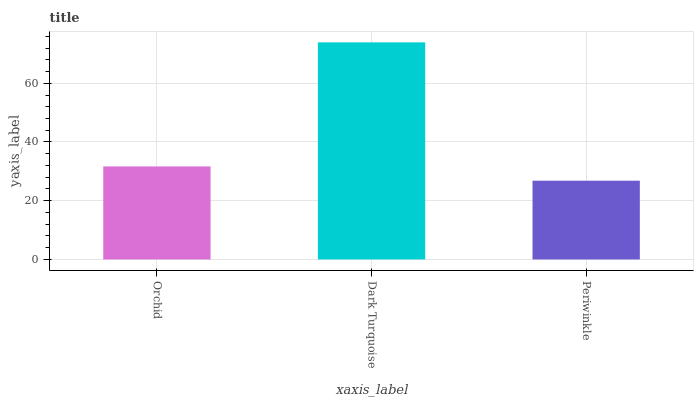Is Periwinkle the minimum?
Answer yes or no. Yes. Is Dark Turquoise the maximum?
Answer yes or no. Yes. Is Dark Turquoise the minimum?
Answer yes or no. No. Is Periwinkle the maximum?
Answer yes or no. No. Is Dark Turquoise greater than Periwinkle?
Answer yes or no. Yes. Is Periwinkle less than Dark Turquoise?
Answer yes or no. Yes. Is Periwinkle greater than Dark Turquoise?
Answer yes or no. No. Is Dark Turquoise less than Periwinkle?
Answer yes or no. No. Is Orchid the high median?
Answer yes or no. Yes. Is Orchid the low median?
Answer yes or no. Yes. Is Periwinkle the high median?
Answer yes or no. No. Is Periwinkle the low median?
Answer yes or no. No. 